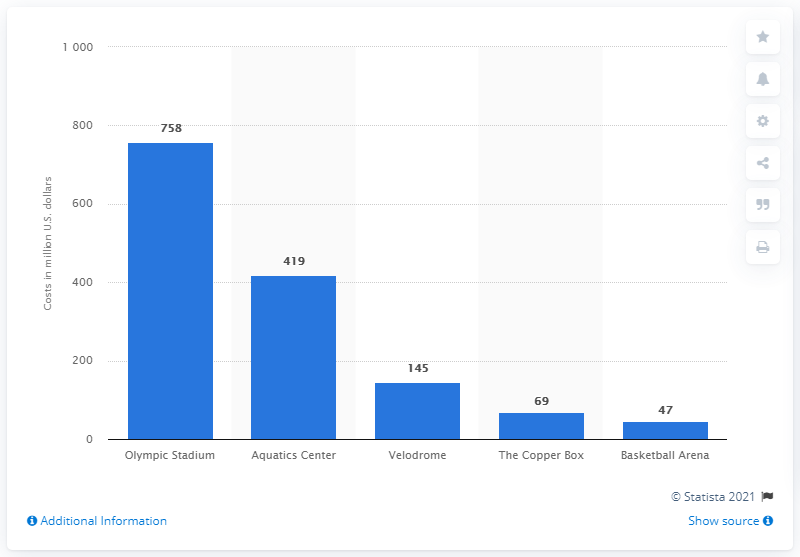Which facility had the highest cost, and how does it compare to the Velodrome? The Olympic Stadium had the highest cost at 758 million US dollars, significantly higher compared to the 145 million US dollars spent on the Velodrome. 